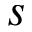<formula> <loc_0><loc_0><loc_500><loc_500>s</formula> 